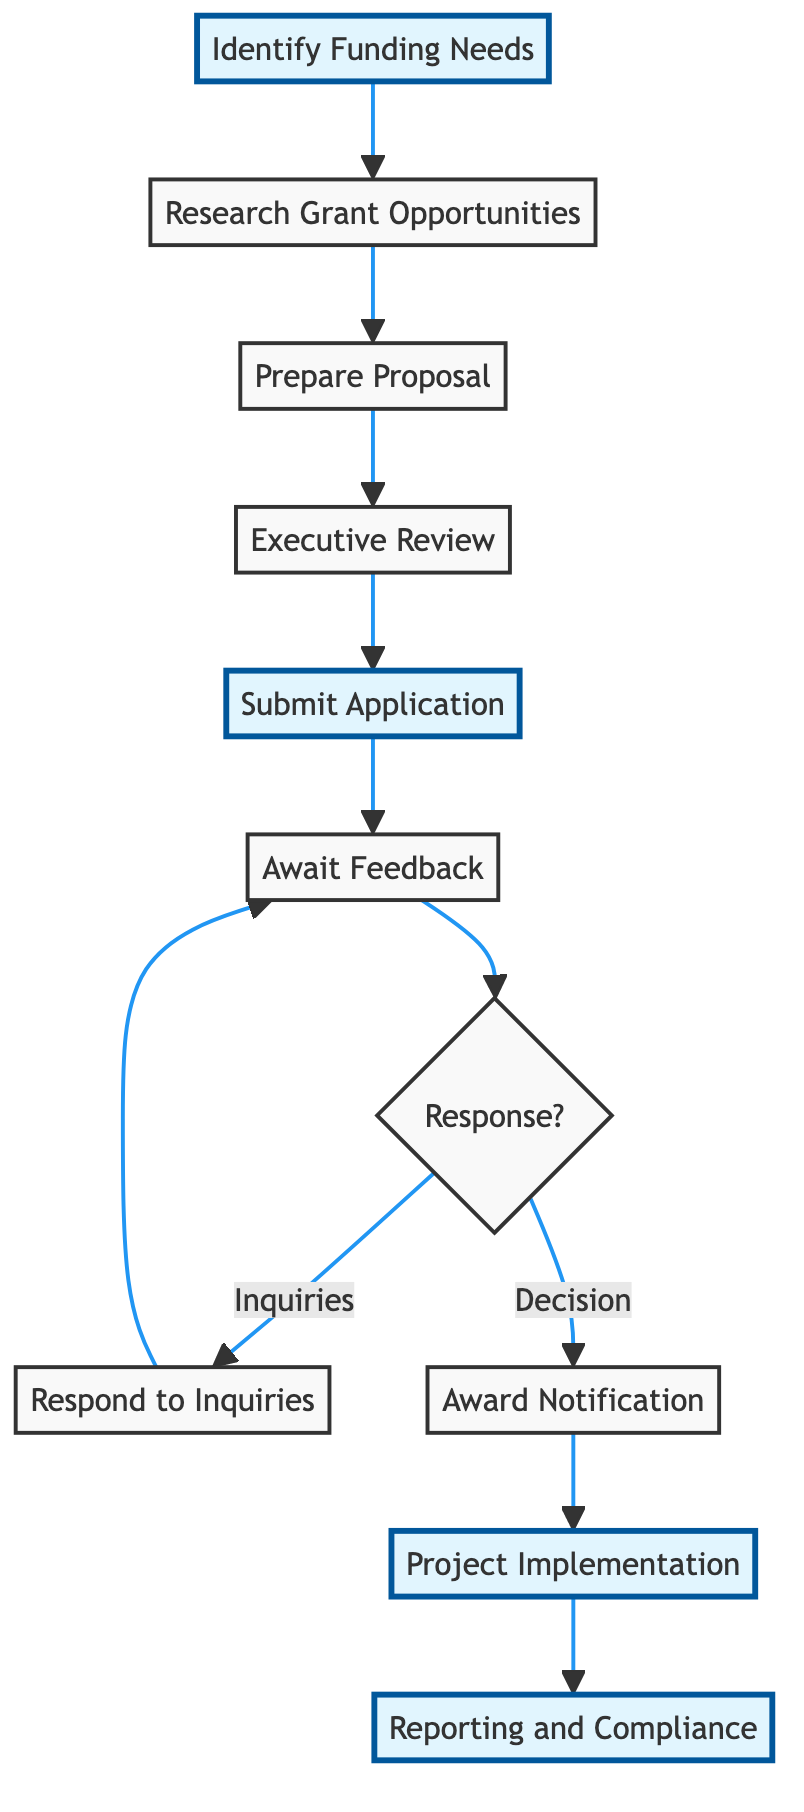What is the first step in the grant application process? The first step in the diagram is "Identify Funding Needs," which is represented as the initial node in the flowchart. It indicates the starting point for outlining specific project goals and financial requirements for the AI climate project.
Answer: Identify Funding Needs How many total steps are in the grant application process? By counting the nodes in the flowchart, we have a total of 10 steps that outline the entire grant application process from identifying needs to reporting and compliance.
Answer: 10 What step comes after "Submit Application"? According to the flowchart, the step that follows "Submit Application" is "Await Feedback." This is the next node that indicates the waiting period for responses from the funding organization.
Answer: Await Feedback Is there a decision point in the process? Yes, the diagram shows a decision node labeled "Response?" which indicates a branching point in the flow where the outcome determines the next steps: either responding to inquiries or receiving an award notification.
Answer: Yes What action is taken after receiving "Award Notification"? After receiving "Award Notification," the next action indicated in the flowchart is "Project Implementation," where the project officially begins based on the proposal and budget agreed upon.
Answer: Project Implementation What happens if there are inquiries after the "Await Feedback" step? If there are inquiries after the "Await Feedback" step, the process loops back to "Respond to Inquiries." This means that additional information is provided to address follow-up questions posed by the funding organization.
Answer: Respond to Inquiries Which step involves high-level management input? The "Executive Review" step involves high-level management input, as it requires executive leadership to review and approve the proposal to ensure it is aligned with company values and goals.
Answer: Executive Review What is the final step of the grant application process? The final step in the grant application process, as depicted in the diagram, is "Reporting and Compliance," which emphasizes the importance of regular progress reporting and adherence to guidelines set by the funding organization.
Answer: Reporting and Compliance 